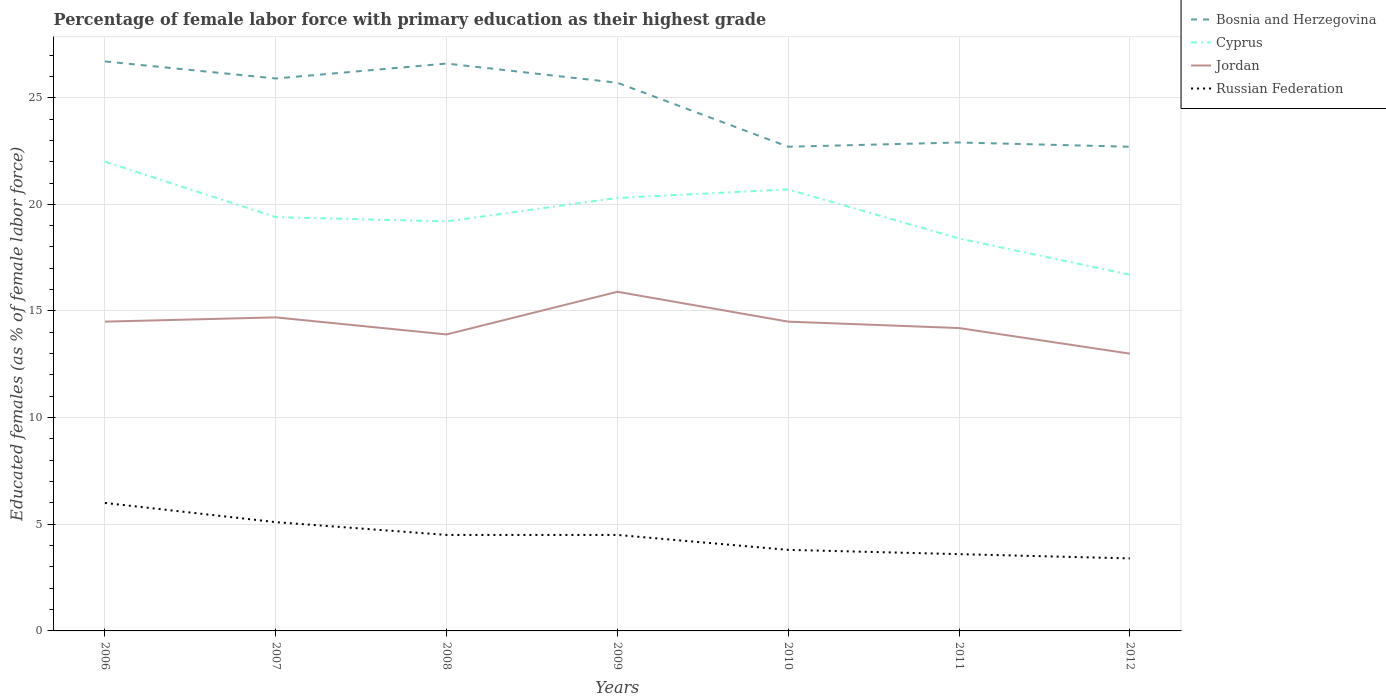Does the line corresponding to Bosnia and Herzegovina intersect with the line corresponding to Russian Federation?
Provide a short and direct response. No. Across all years, what is the maximum percentage of female labor force with primary education in Cyprus?
Offer a very short reply. 16.7. In which year was the percentage of female labor force with primary education in Jordan maximum?
Your response must be concise. 2012. What is the total percentage of female labor force with primary education in Russian Federation in the graph?
Make the answer very short. 0.9. Is the percentage of female labor force with primary education in Jordan strictly greater than the percentage of female labor force with primary education in Cyprus over the years?
Provide a short and direct response. Yes. What is the difference between two consecutive major ticks on the Y-axis?
Make the answer very short. 5. Does the graph contain any zero values?
Keep it short and to the point. No. How many legend labels are there?
Your response must be concise. 4. How are the legend labels stacked?
Offer a terse response. Vertical. What is the title of the graph?
Offer a terse response. Percentage of female labor force with primary education as their highest grade. Does "St. Martin (French part)" appear as one of the legend labels in the graph?
Provide a short and direct response. No. What is the label or title of the Y-axis?
Provide a succinct answer. Educated females (as % of female labor force). What is the Educated females (as % of female labor force) of Bosnia and Herzegovina in 2006?
Provide a succinct answer. 26.7. What is the Educated females (as % of female labor force) in Cyprus in 2006?
Your answer should be compact. 22. What is the Educated females (as % of female labor force) of Bosnia and Herzegovina in 2007?
Offer a terse response. 25.9. What is the Educated females (as % of female labor force) of Cyprus in 2007?
Give a very brief answer. 19.4. What is the Educated females (as % of female labor force) in Jordan in 2007?
Give a very brief answer. 14.7. What is the Educated females (as % of female labor force) in Russian Federation in 2007?
Keep it short and to the point. 5.1. What is the Educated females (as % of female labor force) of Bosnia and Herzegovina in 2008?
Give a very brief answer. 26.6. What is the Educated females (as % of female labor force) in Cyprus in 2008?
Keep it short and to the point. 19.2. What is the Educated females (as % of female labor force) of Jordan in 2008?
Offer a very short reply. 13.9. What is the Educated females (as % of female labor force) of Russian Federation in 2008?
Provide a short and direct response. 4.5. What is the Educated females (as % of female labor force) of Bosnia and Herzegovina in 2009?
Your answer should be very brief. 25.7. What is the Educated females (as % of female labor force) of Cyprus in 2009?
Give a very brief answer. 20.3. What is the Educated females (as % of female labor force) of Jordan in 2009?
Ensure brevity in your answer.  15.9. What is the Educated females (as % of female labor force) of Russian Federation in 2009?
Your response must be concise. 4.5. What is the Educated females (as % of female labor force) in Bosnia and Herzegovina in 2010?
Offer a terse response. 22.7. What is the Educated females (as % of female labor force) in Cyprus in 2010?
Ensure brevity in your answer.  20.7. What is the Educated females (as % of female labor force) of Jordan in 2010?
Offer a very short reply. 14.5. What is the Educated females (as % of female labor force) in Russian Federation in 2010?
Your response must be concise. 3.8. What is the Educated females (as % of female labor force) in Bosnia and Herzegovina in 2011?
Your answer should be very brief. 22.9. What is the Educated females (as % of female labor force) in Cyprus in 2011?
Offer a very short reply. 18.4. What is the Educated females (as % of female labor force) in Jordan in 2011?
Your answer should be compact. 14.2. What is the Educated females (as % of female labor force) of Russian Federation in 2011?
Ensure brevity in your answer.  3.6. What is the Educated females (as % of female labor force) in Bosnia and Herzegovina in 2012?
Provide a short and direct response. 22.7. What is the Educated females (as % of female labor force) of Cyprus in 2012?
Keep it short and to the point. 16.7. What is the Educated females (as % of female labor force) in Jordan in 2012?
Offer a terse response. 13. What is the Educated females (as % of female labor force) of Russian Federation in 2012?
Your answer should be very brief. 3.4. Across all years, what is the maximum Educated females (as % of female labor force) of Bosnia and Herzegovina?
Keep it short and to the point. 26.7. Across all years, what is the maximum Educated females (as % of female labor force) in Jordan?
Ensure brevity in your answer.  15.9. Across all years, what is the minimum Educated females (as % of female labor force) in Bosnia and Herzegovina?
Give a very brief answer. 22.7. Across all years, what is the minimum Educated females (as % of female labor force) of Cyprus?
Provide a short and direct response. 16.7. Across all years, what is the minimum Educated females (as % of female labor force) in Jordan?
Provide a short and direct response. 13. Across all years, what is the minimum Educated females (as % of female labor force) of Russian Federation?
Offer a terse response. 3.4. What is the total Educated females (as % of female labor force) in Bosnia and Herzegovina in the graph?
Offer a very short reply. 173.2. What is the total Educated females (as % of female labor force) in Cyprus in the graph?
Offer a terse response. 136.7. What is the total Educated females (as % of female labor force) of Jordan in the graph?
Keep it short and to the point. 100.7. What is the total Educated females (as % of female labor force) in Russian Federation in the graph?
Your answer should be very brief. 30.9. What is the difference between the Educated females (as % of female labor force) in Bosnia and Herzegovina in 2006 and that in 2007?
Keep it short and to the point. 0.8. What is the difference between the Educated females (as % of female labor force) in Cyprus in 2006 and that in 2007?
Provide a succinct answer. 2.6. What is the difference between the Educated females (as % of female labor force) in Jordan in 2006 and that in 2007?
Make the answer very short. -0.2. What is the difference between the Educated females (as % of female labor force) in Russian Federation in 2006 and that in 2007?
Offer a very short reply. 0.9. What is the difference between the Educated females (as % of female labor force) of Bosnia and Herzegovina in 2006 and that in 2008?
Your answer should be very brief. 0.1. What is the difference between the Educated females (as % of female labor force) of Jordan in 2006 and that in 2009?
Offer a terse response. -1.4. What is the difference between the Educated females (as % of female labor force) in Bosnia and Herzegovina in 2006 and that in 2010?
Your answer should be compact. 4. What is the difference between the Educated females (as % of female labor force) in Cyprus in 2006 and that in 2010?
Provide a succinct answer. 1.3. What is the difference between the Educated females (as % of female labor force) of Bosnia and Herzegovina in 2006 and that in 2011?
Ensure brevity in your answer.  3.8. What is the difference between the Educated females (as % of female labor force) in Bosnia and Herzegovina in 2006 and that in 2012?
Offer a terse response. 4. What is the difference between the Educated females (as % of female labor force) in Cyprus in 2006 and that in 2012?
Your answer should be compact. 5.3. What is the difference between the Educated females (as % of female labor force) in Russian Federation in 2006 and that in 2012?
Keep it short and to the point. 2.6. What is the difference between the Educated females (as % of female labor force) in Bosnia and Herzegovina in 2007 and that in 2008?
Make the answer very short. -0.7. What is the difference between the Educated females (as % of female labor force) of Cyprus in 2007 and that in 2009?
Your answer should be very brief. -0.9. What is the difference between the Educated females (as % of female labor force) in Jordan in 2007 and that in 2010?
Make the answer very short. 0.2. What is the difference between the Educated females (as % of female labor force) in Russian Federation in 2007 and that in 2010?
Ensure brevity in your answer.  1.3. What is the difference between the Educated females (as % of female labor force) in Jordan in 2007 and that in 2011?
Provide a short and direct response. 0.5. What is the difference between the Educated females (as % of female labor force) of Russian Federation in 2007 and that in 2011?
Give a very brief answer. 1.5. What is the difference between the Educated females (as % of female labor force) in Cyprus in 2007 and that in 2012?
Give a very brief answer. 2.7. What is the difference between the Educated females (as % of female labor force) in Jordan in 2007 and that in 2012?
Give a very brief answer. 1.7. What is the difference between the Educated females (as % of female labor force) in Russian Federation in 2007 and that in 2012?
Offer a very short reply. 1.7. What is the difference between the Educated females (as % of female labor force) of Bosnia and Herzegovina in 2008 and that in 2010?
Provide a succinct answer. 3.9. What is the difference between the Educated females (as % of female labor force) of Bosnia and Herzegovina in 2008 and that in 2011?
Ensure brevity in your answer.  3.7. What is the difference between the Educated females (as % of female labor force) of Jordan in 2008 and that in 2011?
Offer a terse response. -0.3. What is the difference between the Educated females (as % of female labor force) of Russian Federation in 2008 and that in 2011?
Keep it short and to the point. 0.9. What is the difference between the Educated females (as % of female labor force) of Jordan in 2008 and that in 2012?
Keep it short and to the point. 0.9. What is the difference between the Educated females (as % of female labor force) of Russian Federation in 2008 and that in 2012?
Your response must be concise. 1.1. What is the difference between the Educated females (as % of female labor force) in Bosnia and Herzegovina in 2009 and that in 2010?
Give a very brief answer. 3. What is the difference between the Educated females (as % of female labor force) of Cyprus in 2009 and that in 2010?
Ensure brevity in your answer.  -0.4. What is the difference between the Educated females (as % of female labor force) of Russian Federation in 2009 and that in 2010?
Provide a short and direct response. 0.7. What is the difference between the Educated females (as % of female labor force) in Bosnia and Herzegovina in 2009 and that in 2011?
Make the answer very short. 2.8. What is the difference between the Educated females (as % of female labor force) in Cyprus in 2009 and that in 2011?
Provide a short and direct response. 1.9. What is the difference between the Educated females (as % of female labor force) of Jordan in 2009 and that in 2011?
Provide a short and direct response. 1.7. What is the difference between the Educated females (as % of female labor force) of Bosnia and Herzegovina in 2009 and that in 2012?
Your response must be concise. 3. What is the difference between the Educated females (as % of female labor force) of Jordan in 2009 and that in 2012?
Ensure brevity in your answer.  2.9. What is the difference between the Educated females (as % of female labor force) in Bosnia and Herzegovina in 2010 and that in 2011?
Your answer should be compact. -0.2. What is the difference between the Educated females (as % of female labor force) of Cyprus in 2010 and that in 2011?
Give a very brief answer. 2.3. What is the difference between the Educated females (as % of female labor force) in Jordan in 2010 and that in 2011?
Ensure brevity in your answer.  0.3. What is the difference between the Educated females (as % of female labor force) in Bosnia and Herzegovina in 2010 and that in 2012?
Provide a succinct answer. 0. What is the difference between the Educated females (as % of female labor force) of Cyprus in 2010 and that in 2012?
Offer a terse response. 4. What is the difference between the Educated females (as % of female labor force) in Jordan in 2010 and that in 2012?
Offer a very short reply. 1.5. What is the difference between the Educated females (as % of female labor force) of Russian Federation in 2010 and that in 2012?
Keep it short and to the point. 0.4. What is the difference between the Educated females (as % of female labor force) of Cyprus in 2011 and that in 2012?
Offer a terse response. 1.7. What is the difference between the Educated females (as % of female labor force) in Jordan in 2011 and that in 2012?
Ensure brevity in your answer.  1.2. What is the difference between the Educated females (as % of female labor force) of Russian Federation in 2011 and that in 2012?
Make the answer very short. 0.2. What is the difference between the Educated females (as % of female labor force) in Bosnia and Herzegovina in 2006 and the Educated females (as % of female labor force) in Cyprus in 2007?
Offer a terse response. 7.3. What is the difference between the Educated females (as % of female labor force) in Bosnia and Herzegovina in 2006 and the Educated females (as % of female labor force) in Jordan in 2007?
Your response must be concise. 12. What is the difference between the Educated females (as % of female labor force) in Bosnia and Herzegovina in 2006 and the Educated females (as % of female labor force) in Russian Federation in 2007?
Your answer should be compact. 21.6. What is the difference between the Educated females (as % of female labor force) in Jordan in 2006 and the Educated females (as % of female labor force) in Russian Federation in 2007?
Offer a very short reply. 9.4. What is the difference between the Educated females (as % of female labor force) of Bosnia and Herzegovina in 2006 and the Educated females (as % of female labor force) of Cyprus in 2008?
Provide a succinct answer. 7.5. What is the difference between the Educated females (as % of female labor force) of Bosnia and Herzegovina in 2006 and the Educated females (as % of female labor force) of Jordan in 2008?
Offer a very short reply. 12.8. What is the difference between the Educated females (as % of female labor force) in Bosnia and Herzegovina in 2006 and the Educated females (as % of female labor force) in Russian Federation in 2008?
Make the answer very short. 22.2. What is the difference between the Educated females (as % of female labor force) in Cyprus in 2006 and the Educated females (as % of female labor force) in Russian Federation in 2008?
Provide a short and direct response. 17.5. What is the difference between the Educated females (as % of female labor force) of Jordan in 2006 and the Educated females (as % of female labor force) of Russian Federation in 2008?
Give a very brief answer. 10. What is the difference between the Educated females (as % of female labor force) of Bosnia and Herzegovina in 2006 and the Educated females (as % of female labor force) of Jordan in 2009?
Make the answer very short. 10.8. What is the difference between the Educated females (as % of female labor force) in Cyprus in 2006 and the Educated females (as % of female labor force) in Jordan in 2009?
Provide a succinct answer. 6.1. What is the difference between the Educated females (as % of female labor force) in Jordan in 2006 and the Educated females (as % of female labor force) in Russian Federation in 2009?
Ensure brevity in your answer.  10. What is the difference between the Educated females (as % of female labor force) in Bosnia and Herzegovina in 2006 and the Educated females (as % of female labor force) in Jordan in 2010?
Ensure brevity in your answer.  12.2. What is the difference between the Educated females (as % of female labor force) in Bosnia and Herzegovina in 2006 and the Educated females (as % of female labor force) in Russian Federation in 2010?
Make the answer very short. 22.9. What is the difference between the Educated females (as % of female labor force) of Jordan in 2006 and the Educated females (as % of female labor force) of Russian Federation in 2010?
Ensure brevity in your answer.  10.7. What is the difference between the Educated females (as % of female labor force) of Bosnia and Herzegovina in 2006 and the Educated females (as % of female labor force) of Cyprus in 2011?
Offer a very short reply. 8.3. What is the difference between the Educated females (as % of female labor force) of Bosnia and Herzegovina in 2006 and the Educated females (as % of female labor force) of Russian Federation in 2011?
Provide a short and direct response. 23.1. What is the difference between the Educated females (as % of female labor force) of Jordan in 2006 and the Educated females (as % of female labor force) of Russian Federation in 2011?
Keep it short and to the point. 10.9. What is the difference between the Educated females (as % of female labor force) of Bosnia and Herzegovina in 2006 and the Educated females (as % of female labor force) of Jordan in 2012?
Keep it short and to the point. 13.7. What is the difference between the Educated females (as % of female labor force) in Bosnia and Herzegovina in 2006 and the Educated females (as % of female labor force) in Russian Federation in 2012?
Give a very brief answer. 23.3. What is the difference between the Educated females (as % of female labor force) of Cyprus in 2006 and the Educated females (as % of female labor force) of Jordan in 2012?
Offer a terse response. 9. What is the difference between the Educated females (as % of female labor force) in Bosnia and Herzegovina in 2007 and the Educated females (as % of female labor force) in Cyprus in 2008?
Offer a very short reply. 6.7. What is the difference between the Educated females (as % of female labor force) in Bosnia and Herzegovina in 2007 and the Educated females (as % of female labor force) in Russian Federation in 2008?
Make the answer very short. 21.4. What is the difference between the Educated females (as % of female labor force) in Jordan in 2007 and the Educated females (as % of female labor force) in Russian Federation in 2008?
Provide a short and direct response. 10.2. What is the difference between the Educated females (as % of female labor force) in Bosnia and Herzegovina in 2007 and the Educated females (as % of female labor force) in Russian Federation in 2009?
Make the answer very short. 21.4. What is the difference between the Educated females (as % of female labor force) of Cyprus in 2007 and the Educated females (as % of female labor force) of Jordan in 2009?
Offer a very short reply. 3.5. What is the difference between the Educated females (as % of female labor force) of Bosnia and Herzegovina in 2007 and the Educated females (as % of female labor force) of Cyprus in 2010?
Keep it short and to the point. 5.2. What is the difference between the Educated females (as % of female labor force) in Bosnia and Herzegovina in 2007 and the Educated females (as % of female labor force) in Jordan in 2010?
Make the answer very short. 11.4. What is the difference between the Educated females (as % of female labor force) of Bosnia and Herzegovina in 2007 and the Educated females (as % of female labor force) of Russian Federation in 2010?
Your answer should be very brief. 22.1. What is the difference between the Educated females (as % of female labor force) in Cyprus in 2007 and the Educated females (as % of female labor force) in Russian Federation in 2010?
Provide a succinct answer. 15.6. What is the difference between the Educated females (as % of female labor force) in Jordan in 2007 and the Educated females (as % of female labor force) in Russian Federation in 2010?
Your answer should be very brief. 10.9. What is the difference between the Educated females (as % of female labor force) of Bosnia and Herzegovina in 2007 and the Educated females (as % of female labor force) of Cyprus in 2011?
Offer a very short reply. 7.5. What is the difference between the Educated females (as % of female labor force) in Bosnia and Herzegovina in 2007 and the Educated females (as % of female labor force) in Russian Federation in 2011?
Give a very brief answer. 22.3. What is the difference between the Educated females (as % of female labor force) in Cyprus in 2007 and the Educated females (as % of female labor force) in Jordan in 2011?
Provide a short and direct response. 5.2. What is the difference between the Educated females (as % of female labor force) of Cyprus in 2007 and the Educated females (as % of female labor force) of Russian Federation in 2011?
Offer a terse response. 15.8. What is the difference between the Educated females (as % of female labor force) in Jordan in 2007 and the Educated females (as % of female labor force) in Russian Federation in 2011?
Offer a terse response. 11.1. What is the difference between the Educated females (as % of female labor force) of Bosnia and Herzegovina in 2007 and the Educated females (as % of female labor force) of Cyprus in 2012?
Your response must be concise. 9.2. What is the difference between the Educated females (as % of female labor force) in Bosnia and Herzegovina in 2007 and the Educated females (as % of female labor force) in Jordan in 2012?
Provide a short and direct response. 12.9. What is the difference between the Educated females (as % of female labor force) in Bosnia and Herzegovina in 2007 and the Educated females (as % of female labor force) in Russian Federation in 2012?
Make the answer very short. 22.5. What is the difference between the Educated females (as % of female labor force) of Jordan in 2007 and the Educated females (as % of female labor force) of Russian Federation in 2012?
Offer a terse response. 11.3. What is the difference between the Educated females (as % of female labor force) of Bosnia and Herzegovina in 2008 and the Educated females (as % of female labor force) of Jordan in 2009?
Give a very brief answer. 10.7. What is the difference between the Educated females (as % of female labor force) in Bosnia and Herzegovina in 2008 and the Educated females (as % of female labor force) in Russian Federation in 2009?
Your response must be concise. 22.1. What is the difference between the Educated females (as % of female labor force) of Bosnia and Herzegovina in 2008 and the Educated females (as % of female labor force) of Russian Federation in 2010?
Provide a succinct answer. 22.8. What is the difference between the Educated females (as % of female labor force) of Cyprus in 2008 and the Educated females (as % of female labor force) of Russian Federation in 2010?
Make the answer very short. 15.4. What is the difference between the Educated females (as % of female labor force) of Bosnia and Herzegovina in 2008 and the Educated females (as % of female labor force) of Cyprus in 2011?
Make the answer very short. 8.2. What is the difference between the Educated females (as % of female labor force) in Bosnia and Herzegovina in 2008 and the Educated females (as % of female labor force) in Russian Federation in 2011?
Your response must be concise. 23. What is the difference between the Educated females (as % of female labor force) of Cyprus in 2008 and the Educated females (as % of female labor force) of Russian Federation in 2011?
Your response must be concise. 15.6. What is the difference between the Educated females (as % of female labor force) in Jordan in 2008 and the Educated females (as % of female labor force) in Russian Federation in 2011?
Make the answer very short. 10.3. What is the difference between the Educated females (as % of female labor force) in Bosnia and Herzegovina in 2008 and the Educated females (as % of female labor force) in Jordan in 2012?
Give a very brief answer. 13.6. What is the difference between the Educated females (as % of female labor force) in Bosnia and Herzegovina in 2008 and the Educated females (as % of female labor force) in Russian Federation in 2012?
Offer a terse response. 23.2. What is the difference between the Educated females (as % of female labor force) in Cyprus in 2008 and the Educated females (as % of female labor force) in Russian Federation in 2012?
Ensure brevity in your answer.  15.8. What is the difference between the Educated females (as % of female labor force) of Bosnia and Herzegovina in 2009 and the Educated females (as % of female labor force) of Jordan in 2010?
Ensure brevity in your answer.  11.2. What is the difference between the Educated females (as % of female labor force) in Bosnia and Herzegovina in 2009 and the Educated females (as % of female labor force) in Russian Federation in 2010?
Give a very brief answer. 21.9. What is the difference between the Educated females (as % of female labor force) in Jordan in 2009 and the Educated females (as % of female labor force) in Russian Federation in 2010?
Provide a short and direct response. 12.1. What is the difference between the Educated females (as % of female labor force) of Bosnia and Herzegovina in 2009 and the Educated females (as % of female labor force) of Jordan in 2011?
Your answer should be very brief. 11.5. What is the difference between the Educated females (as % of female labor force) of Bosnia and Herzegovina in 2009 and the Educated females (as % of female labor force) of Russian Federation in 2011?
Your answer should be compact. 22.1. What is the difference between the Educated females (as % of female labor force) in Jordan in 2009 and the Educated females (as % of female labor force) in Russian Federation in 2011?
Provide a short and direct response. 12.3. What is the difference between the Educated females (as % of female labor force) in Bosnia and Herzegovina in 2009 and the Educated females (as % of female labor force) in Russian Federation in 2012?
Ensure brevity in your answer.  22.3. What is the difference between the Educated females (as % of female labor force) of Jordan in 2009 and the Educated females (as % of female labor force) of Russian Federation in 2012?
Ensure brevity in your answer.  12.5. What is the difference between the Educated females (as % of female labor force) of Bosnia and Herzegovina in 2010 and the Educated females (as % of female labor force) of Cyprus in 2011?
Your response must be concise. 4.3. What is the difference between the Educated females (as % of female labor force) in Bosnia and Herzegovina in 2010 and the Educated females (as % of female labor force) in Jordan in 2011?
Offer a terse response. 8.5. What is the difference between the Educated females (as % of female labor force) of Bosnia and Herzegovina in 2010 and the Educated females (as % of female labor force) of Russian Federation in 2011?
Provide a succinct answer. 19.1. What is the difference between the Educated females (as % of female labor force) in Cyprus in 2010 and the Educated females (as % of female labor force) in Jordan in 2011?
Make the answer very short. 6.5. What is the difference between the Educated females (as % of female labor force) of Jordan in 2010 and the Educated females (as % of female labor force) of Russian Federation in 2011?
Make the answer very short. 10.9. What is the difference between the Educated females (as % of female labor force) in Bosnia and Herzegovina in 2010 and the Educated females (as % of female labor force) in Cyprus in 2012?
Your response must be concise. 6. What is the difference between the Educated females (as % of female labor force) in Bosnia and Herzegovina in 2010 and the Educated females (as % of female labor force) in Russian Federation in 2012?
Make the answer very short. 19.3. What is the difference between the Educated females (as % of female labor force) of Cyprus in 2010 and the Educated females (as % of female labor force) of Jordan in 2012?
Give a very brief answer. 7.7. What is the difference between the Educated females (as % of female labor force) in Cyprus in 2011 and the Educated females (as % of female labor force) in Jordan in 2012?
Your answer should be very brief. 5.4. What is the difference between the Educated females (as % of female labor force) of Jordan in 2011 and the Educated females (as % of female labor force) of Russian Federation in 2012?
Your response must be concise. 10.8. What is the average Educated females (as % of female labor force) in Bosnia and Herzegovina per year?
Make the answer very short. 24.74. What is the average Educated females (as % of female labor force) of Cyprus per year?
Ensure brevity in your answer.  19.53. What is the average Educated females (as % of female labor force) in Jordan per year?
Offer a very short reply. 14.39. What is the average Educated females (as % of female labor force) of Russian Federation per year?
Keep it short and to the point. 4.41. In the year 2006, what is the difference between the Educated females (as % of female labor force) of Bosnia and Herzegovina and Educated females (as % of female labor force) of Jordan?
Make the answer very short. 12.2. In the year 2006, what is the difference between the Educated females (as % of female labor force) of Bosnia and Herzegovina and Educated females (as % of female labor force) of Russian Federation?
Provide a succinct answer. 20.7. In the year 2007, what is the difference between the Educated females (as % of female labor force) in Bosnia and Herzegovina and Educated females (as % of female labor force) in Russian Federation?
Give a very brief answer. 20.8. In the year 2007, what is the difference between the Educated females (as % of female labor force) in Cyprus and Educated females (as % of female labor force) in Russian Federation?
Your answer should be compact. 14.3. In the year 2007, what is the difference between the Educated females (as % of female labor force) of Jordan and Educated females (as % of female labor force) of Russian Federation?
Offer a very short reply. 9.6. In the year 2008, what is the difference between the Educated females (as % of female labor force) of Bosnia and Herzegovina and Educated females (as % of female labor force) of Cyprus?
Provide a succinct answer. 7.4. In the year 2008, what is the difference between the Educated females (as % of female labor force) in Bosnia and Herzegovina and Educated females (as % of female labor force) in Russian Federation?
Provide a succinct answer. 22.1. In the year 2008, what is the difference between the Educated females (as % of female labor force) in Cyprus and Educated females (as % of female labor force) in Jordan?
Your response must be concise. 5.3. In the year 2008, what is the difference between the Educated females (as % of female labor force) of Cyprus and Educated females (as % of female labor force) of Russian Federation?
Offer a terse response. 14.7. In the year 2008, what is the difference between the Educated females (as % of female labor force) of Jordan and Educated females (as % of female labor force) of Russian Federation?
Ensure brevity in your answer.  9.4. In the year 2009, what is the difference between the Educated females (as % of female labor force) of Bosnia and Herzegovina and Educated females (as % of female labor force) of Cyprus?
Provide a succinct answer. 5.4. In the year 2009, what is the difference between the Educated females (as % of female labor force) in Bosnia and Herzegovina and Educated females (as % of female labor force) in Jordan?
Your response must be concise. 9.8. In the year 2009, what is the difference between the Educated females (as % of female labor force) of Bosnia and Herzegovina and Educated females (as % of female labor force) of Russian Federation?
Your answer should be compact. 21.2. In the year 2009, what is the difference between the Educated females (as % of female labor force) in Cyprus and Educated females (as % of female labor force) in Jordan?
Your answer should be compact. 4.4. In the year 2009, what is the difference between the Educated females (as % of female labor force) of Cyprus and Educated females (as % of female labor force) of Russian Federation?
Offer a very short reply. 15.8. In the year 2009, what is the difference between the Educated females (as % of female labor force) of Jordan and Educated females (as % of female labor force) of Russian Federation?
Provide a succinct answer. 11.4. In the year 2010, what is the difference between the Educated females (as % of female labor force) in Bosnia and Herzegovina and Educated females (as % of female labor force) in Cyprus?
Give a very brief answer. 2. In the year 2010, what is the difference between the Educated females (as % of female labor force) in Bosnia and Herzegovina and Educated females (as % of female labor force) in Russian Federation?
Keep it short and to the point. 18.9. In the year 2011, what is the difference between the Educated females (as % of female labor force) in Bosnia and Herzegovina and Educated females (as % of female labor force) in Cyprus?
Your answer should be compact. 4.5. In the year 2011, what is the difference between the Educated females (as % of female labor force) of Bosnia and Herzegovina and Educated females (as % of female labor force) of Jordan?
Offer a very short reply. 8.7. In the year 2011, what is the difference between the Educated females (as % of female labor force) of Bosnia and Herzegovina and Educated females (as % of female labor force) of Russian Federation?
Give a very brief answer. 19.3. In the year 2011, what is the difference between the Educated females (as % of female labor force) of Cyprus and Educated females (as % of female labor force) of Russian Federation?
Give a very brief answer. 14.8. In the year 2012, what is the difference between the Educated females (as % of female labor force) of Bosnia and Herzegovina and Educated females (as % of female labor force) of Cyprus?
Give a very brief answer. 6. In the year 2012, what is the difference between the Educated females (as % of female labor force) in Bosnia and Herzegovina and Educated females (as % of female labor force) in Jordan?
Offer a very short reply. 9.7. In the year 2012, what is the difference between the Educated females (as % of female labor force) of Bosnia and Herzegovina and Educated females (as % of female labor force) of Russian Federation?
Your answer should be compact. 19.3. In the year 2012, what is the difference between the Educated females (as % of female labor force) of Jordan and Educated females (as % of female labor force) of Russian Federation?
Your answer should be very brief. 9.6. What is the ratio of the Educated females (as % of female labor force) in Bosnia and Herzegovina in 2006 to that in 2007?
Provide a succinct answer. 1.03. What is the ratio of the Educated females (as % of female labor force) in Cyprus in 2006 to that in 2007?
Provide a succinct answer. 1.13. What is the ratio of the Educated females (as % of female labor force) in Jordan in 2006 to that in 2007?
Provide a short and direct response. 0.99. What is the ratio of the Educated females (as % of female labor force) in Russian Federation in 2006 to that in 2007?
Make the answer very short. 1.18. What is the ratio of the Educated females (as % of female labor force) of Cyprus in 2006 to that in 2008?
Your answer should be very brief. 1.15. What is the ratio of the Educated females (as % of female labor force) in Jordan in 2006 to that in 2008?
Give a very brief answer. 1.04. What is the ratio of the Educated females (as % of female labor force) in Russian Federation in 2006 to that in 2008?
Ensure brevity in your answer.  1.33. What is the ratio of the Educated females (as % of female labor force) in Bosnia and Herzegovina in 2006 to that in 2009?
Make the answer very short. 1.04. What is the ratio of the Educated females (as % of female labor force) in Cyprus in 2006 to that in 2009?
Your answer should be very brief. 1.08. What is the ratio of the Educated females (as % of female labor force) in Jordan in 2006 to that in 2009?
Make the answer very short. 0.91. What is the ratio of the Educated females (as % of female labor force) in Russian Federation in 2006 to that in 2009?
Provide a short and direct response. 1.33. What is the ratio of the Educated females (as % of female labor force) in Bosnia and Herzegovina in 2006 to that in 2010?
Your answer should be compact. 1.18. What is the ratio of the Educated females (as % of female labor force) of Cyprus in 2006 to that in 2010?
Provide a short and direct response. 1.06. What is the ratio of the Educated females (as % of female labor force) of Russian Federation in 2006 to that in 2010?
Give a very brief answer. 1.58. What is the ratio of the Educated females (as % of female labor force) of Bosnia and Herzegovina in 2006 to that in 2011?
Give a very brief answer. 1.17. What is the ratio of the Educated females (as % of female labor force) of Cyprus in 2006 to that in 2011?
Your answer should be very brief. 1.2. What is the ratio of the Educated females (as % of female labor force) in Jordan in 2006 to that in 2011?
Provide a succinct answer. 1.02. What is the ratio of the Educated females (as % of female labor force) of Bosnia and Herzegovina in 2006 to that in 2012?
Ensure brevity in your answer.  1.18. What is the ratio of the Educated females (as % of female labor force) of Cyprus in 2006 to that in 2012?
Provide a short and direct response. 1.32. What is the ratio of the Educated females (as % of female labor force) of Jordan in 2006 to that in 2012?
Give a very brief answer. 1.12. What is the ratio of the Educated females (as % of female labor force) in Russian Federation in 2006 to that in 2012?
Provide a short and direct response. 1.76. What is the ratio of the Educated females (as % of female labor force) of Bosnia and Herzegovina in 2007 to that in 2008?
Make the answer very short. 0.97. What is the ratio of the Educated females (as % of female labor force) in Cyprus in 2007 to that in 2008?
Ensure brevity in your answer.  1.01. What is the ratio of the Educated females (as % of female labor force) of Jordan in 2007 to that in 2008?
Provide a succinct answer. 1.06. What is the ratio of the Educated females (as % of female labor force) in Russian Federation in 2007 to that in 2008?
Ensure brevity in your answer.  1.13. What is the ratio of the Educated females (as % of female labor force) in Bosnia and Herzegovina in 2007 to that in 2009?
Offer a terse response. 1.01. What is the ratio of the Educated females (as % of female labor force) of Cyprus in 2007 to that in 2009?
Offer a terse response. 0.96. What is the ratio of the Educated females (as % of female labor force) in Jordan in 2007 to that in 2009?
Keep it short and to the point. 0.92. What is the ratio of the Educated females (as % of female labor force) in Russian Federation in 2007 to that in 2009?
Offer a terse response. 1.13. What is the ratio of the Educated females (as % of female labor force) of Bosnia and Herzegovina in 2007 to that in 2010?
Keep it short and to the point. 1.14. What is the ratio of the Educated females (as % of female labor force) of Cyprus in 2007 to that in 2010?
Your response must be concise. 0.94. What is the ratio of the Educated females (as % of female labor force) in Jordan in 2007 to that in 2010?
Ensure brevity in your answer.  1.01. What is the ratio of the Educated females (as % of female labor force) in Russian Federation in 2007 to that in 2010?
Your answer should be compact. 1.34. What is the ratio of the Educated females (as % of female labor force) in Bosnia and Herzegovina in 2007 to that in 2011?
Give a very brief answer. 1.13. What is the ratio of the Educated females (as % of female labor force) in Cyprus in 2007 to that in 2011?
Your answer should be very brief. 1.05. What is the ratio of the Educated females (as % of female labor force) in Jordan in 2007 to that in 2011?
Provide a succinct answer. 1.04. What is the ratio of the Educated females (as % of female labor force) in Russian Federation in 2007 to that in 2011?
Your answer should be compact. 1.42. What is the ratio of the Educated females (as % of female labor force) in Bosnia and Herzegovina in 2007 to that in 2012?
Ensure brevity in your answer.  1.14. What is the ratio of the Educated females (as % of female labor force) in Cyprus in 2007 to that in 2012?
Your answer should be compact. 1.16. What is the ratio of the Educated females (as % of female labor force) of Jordan in 2007 to that in 2012?
Offer a very short reply. 1.13. What is the ratio of the Educated females (as % of female labor force) of Russian Federation in 2007 to that in 2012?
Provide a short and direct response. 1.5. What is the ratio of the Educated females (as % of female labor force) of Bosnia and Herzegovina in 2008 to that in 2009?
Your answer should be compact. 1.03. What is the ratio of the Educated females (as % of female labor force) of Cyprus in 2008 to that in 2009?
Offer a very short reply. 0.95. What is the ratio of the Educated females (as % of female labor force) in Jordan in 2008 to that in 2009?
Give a very brief answer. 0.87. What is the ratio of the Educated females (as % of female labor force) of Russian Federation in 2008 to that in 2009?
Provide a short and direct response. 1. What is the ratio of the Educated females (as % of female labor force) in Bosnia and Herzegovina in 2008 to that in 2010?
Provide a short and direct response. 1.17. What is the ratio of the Educated females (as % of female labor force) in Cyprus in 2008 to that in 2010?
Give a very brief answer. 0.93. What is the ratio of the Educated females (as % of female labor force) in Jordan in 2008 to that in 2010?
Your answer should be very brief. 0.96. What is the ratio of the Educated females (as % of female labor force) of Russian Federation in 2008 to that in 2010?
Your answer should be very brief. 1.18. What is the ratio of the Educated females (as % of female labor force) of Bosnia and Herzegovina in 2008 to that in 2011?
Your answer should be compact. 1.16. What is the ratio of the Educated females (as % of female labor force) in Cyprus in 2008 to that in 2011?
Provide a succinct answer. 1.04. What is the ratio of the Educated females (as % of female labor force) in Jordan in 2008 to that in 2011?
Offer a terse response. 0.98. What is the ratio of the Educated females (as % of female labor force) of Russian Federation in 2008 to that in 2011?
Provide a short and direct response. 1.25. What is the ratio of the Educated females (as % of female labor force) of Bosnia and Herzegovina in 2008 to that in 2012?
Ensure brevity in your answer.  1.17. What is the ratio of the Educated females (as % of female labor force) in Cyprus in 2008 to that in 2012?
Ensure brevity in your answer.  1.15. What is the ratio of the Educated females (as % of female labor force) of Jordan in 2008 to that in 2012?
Ensure brevity in your answer.  1.07. What is the ratio of the Educated females (as % of female labor force) of Russian Federation in 2008 to that in 2012?
Ensure brevity in your answer.  1.32. What is the ratio of the Educated females (as % of female labor force) in Bosnia and Herzegovina in 2009 to that in 2010?
Keep it short and to the point. 1.13. What is the ratio of the Educated females (as % of female labor force) of Cyprus in 2009 to that in 2010?
Make the answer very short. 0.98. What is the ratio of the Educated females (as % of female labor force) in Jordan in 2009 to that in 2010?
Your answer should be very brief. 1.1. What is the ratio of the Educated females (as % of female labor force) of Russian Federation in 2009 to that in 2010?
Ensure brevity in your answer.  1.18. What is the ratio of the Educated females (as % of female labor force) of Bosnia and Herzegovina in 2009 to that in 2011?
Provide a succinct answer. 1.12. What is the ratio of the Educated females (as % of female labor force) in Cyprus in 2009 to that in 2011?
Provide a short and direct response. 1.1. What is the ratio of the Educated females (as % of female labor force) in Jordan in 2009 to that in 2011?
Offer a terse response. 1.12. What is the ratio of the Educated females (as % of female labor force) of Russian Federation in 2009 to that in 2011?
Make the answer very short. 1.25. What is the ratio of the Educated females (as % of female labor force) of Bosnia and Herzegovina in 2009 to that in 2012?
Your answer should be very brief. 1.13. What is the ratio of the Educated females (as % of female labor force) in Cyprus in 2009 to that in 2012?
Offer a very short reply. 1.22. What is the ratio of the Educated females (as % of female labor force) in Jordan in 2009 to that in 2012?
Provide a succinct answer. 1.22. What is the ratio of the Educated females (as % of female labor force) in Russian Federation in 2009 to that in 2012?
Provide a succinct answer. 1.32. What is the ratio of the Educated females (as % of female labor force) of Cyprus in 2010 to that in 2011?
Offer a terse response. 1.12. What is the ratio of the Educated females (as % of female labor force) of Jordan in 2010 to that in 2011?
Ensure brevity in your answer.  1.02. What is the ratio of the Educated females (as % of female labor force) of Russian Federation in 2010 to that in 2011?
Provide a succinct answer. 1.06. What is the ratio of the Educated females (as % of female labor force) in Bosnia and Herzegovina in 2010 to that in 2012?
Your answer should be compact. 1. What is the ratio of the Educated females (as % of female labor force) in Cyprus in 2010 to that in 2012?
Offer a terse response. 1.24. What is the ratio of the Educated females (as % of female labor force) of Jordan in 2010 to that in 2012?
Make the answer very short. 1.12. What is the ratio of the Educated females (as % of female labor force) in Russian Federation in 2010 to that in 2012?
Give a very brief answer. 1.12. What is the ratio of the Educated females (as % of female labor force) in Bosnia and Herzegovina in 2011 to that in 2012?
Provide a succinct answer. 1.01. What is the ratio of the Educated females (as % of female labor force) in Cyprus in 2011 to that in 2012?
Make the answer very short. 1.1. What is the ratio of the Educated females (as % of female labor force) in Jordan in 2011 to that in 2012?
Your response must be concise. 1.09. What is the ratio of the Educated females (as % of female labor force) in Russian Federation in 2011 to that in 2012?
Your answer should be very brief. 1.06. What is the difference between the highest and the second highest Educated females (as % of female labor force) in Russian Federation?
Provide a short and direct response. 0.9. What is the difference between the highest and the lowest Educated females (as % of female labor force) of Bosnia and Herzegovina?
Give a very brief answer. 4. What is the difference between the highest and the lowest Educated females (as % of female labor force) of Cyprus?
Your answer should be very brief. 5.3. 